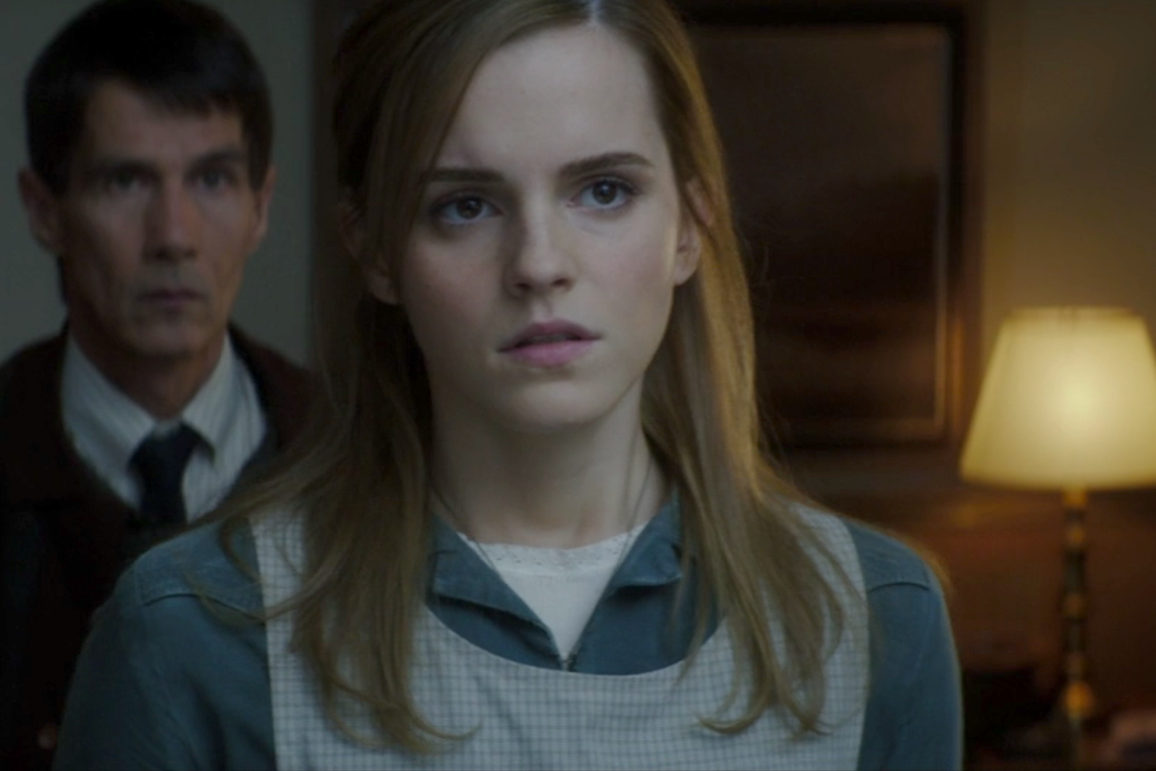What might these characters be thinking in this intense moment? The woman is likely thinking through the ramifications of the revelation she has just made or witnessed, trying to process the flood of emotions. She might be contemplating the steps she needs to take next, weighing the risks and thinking of possible outcomes. The man, on the other hand, could be dealing with the realization that his actions or identity have been exposed. He might be calculating his next move, trying to assess how much the woman knows and planning how to control the situation to his advantage. The shared focus of their gazes suggests they are both mentally preparing for whatever comes next, locked in a psychological battle. 